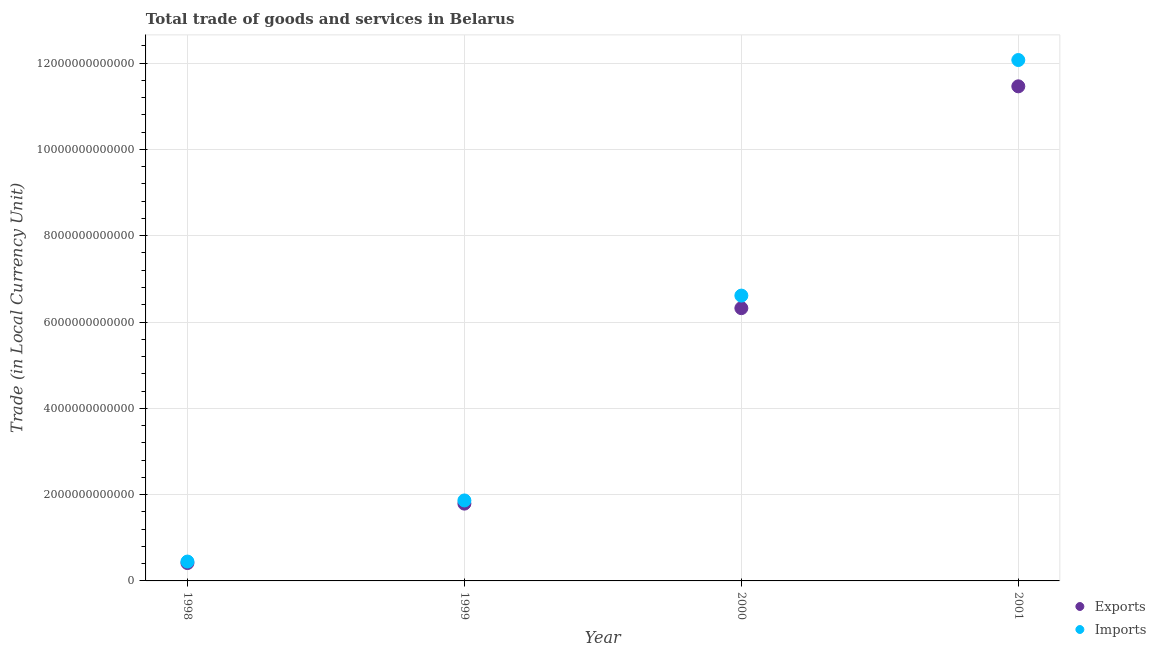What is the export of goods and services in 1998?
Ensure brevity in your answer.  4.15e+11. Across all years, what is the maximum imports of goods and services?
Your answer should be compact. 1.21e+13. Across all years, what is the minimum export of goods and services?
Offer a terse response. 4.15e+11. In which year was the export of goods and services maximum?
Give a very brief answer. 2001. In which year was the imports of goods and services minimum?
Give a very brief answer. 1998. What is the total imports of goods and services in the graph?
Offer a very short reply. 2.10e+13. What is the difference between the imports of goods and services in 1998 and that in 2001?
Ensure brevity in your answer.  -1.16e+13. What is the difference between the export of goods and services in 1998 and the imports of goods and services in 2000?
Keep it short and to the point. -6.20e+12. What is the average imports of goods and services per year?
Offer a very short reply. 5.25e+12. In the year 1998, what is the difference between the export of goods and services and imports of goods and services?
Your answer should be compact. -3.41e+1. What is the ratio of the imports of goods and services in 1998 to that in 1999?
Your answer should be compact. 0.24. What is the difference between the highest and the second highest export of goods and services?
Offer a very short reply. 5.14e+12. What is the difference between the highest and the lowest imports of goods and services?
Your answer should be very brief. 1.16e+13. In how many years, is the export of goods and services greater than the average export of goods and services taken over all years?
Your answer should be very brief. 2. Does the export of goods and services monotonically increase over the years?
Provide a succinct answer. Yes. Is the imports of goods and services strictly less than the export of goods and services over the years?
Make the answer very short. No. How many dotlines are there?
Your response must be concise. 2. What is the difference between two consecutive major ticks on the Y-axis?
Your answer should be very brief. 2.00e+12. Does the graph contain any zero values?
Your answer should be very brief. No. How many legend labels are there?
Provide a short and direct response. 2. What is the title of the graph?
Your answer should be very brief. Total trade of goods and services in Belarus. Does "GDP per capita" appear as one of the legend labels in the graph?
Your answer should be very brief. No. What is the label or title of the X-axis?
Your response must be concise. Year. What is the label or title of the Y-axis?
Ensure brevity in your answer.  Trade (in Local Currency Unit). What is the Trade (in Local Currency Unit) in Exports in 1998?
Keep it short and to the point. 4.15e+11. What is the Trade (in Local Currency Unit) of Imports in 1998?
Your answer should be compact. 4.49e+11. What is the Trade (in Local Currency Unit) in Exports in 1999?
Keep it short and to the point. 1.79e+12. What is the Trade (in Local Currency Unit) in Imports in 1999?
Keep it short and to the point. 1.87e+12. What is the Trade (in Local Currency Unit) in Exports in 2000?
Your answer should be compact. 6.32e+12. What is the Trade (in Local Currency Unit) in Imports in 2000?
Ensure brevity in your answer.  6.61e+12. What is the Trade (in Local Currency Unit) of Exports in 2001?
Offer a very short reply. 1.15e+13. What is the Trade (in Local Currency Unit) in Imports in 2001?
Provide a succinct answer. 1.21e+13. Across all years, what is the maximum Trade (in Local Currency Unit) of Exports?
Keep it short and to the point. 1.15e+13. Across all years, what is the maximum Trade (in Local Currency Unit) of Imports?
Make the answer very short. 1.21e+13. Across all years, what is the minimum Trade (in Local Currency Unit) of Exports?
Your answer should be very brief. 4.15e+11. Across all years, what is the minimum Trade (in Local Currency Unit) of Imports?
Your answer should be compact. 4.49e+11. What is the total Trade (in Local Currency Unit) of Exports in the graph?
Provide a short and direct response. 2.00e+13. What is the total Trade (in Local Currency Unit) of Imports in the graph?
Make the answer very short. 2.10e+13. What is the difference between the Trade (in Local Currency Unit) of Exports in 1998 and that in 1999?
Your response must be concise. -1.38e+12. What is the difference between the Trade (in Local Currency Unit) in Imports in 1998 and that in 1999?
Your answer should be very brief. -1.42e+12. What is the difference between the Trade (in Local Currency Unit) of Exports in 1998 and that in 2000?
Offer a very short reply. -5.91e+12. What is the difference between the Trade (in Local Currency Unit) in Imports in 1998 and that in 2000?
Make the answer very short. -6.16e+12. What is the difference between the Trade (in Local Currency Unit) in Exports in 1998 and that in 2001?
Provide a short and direct response. -1.10e+13. What is the difference between the Trade (in Local Currency Unit) in Imports in 1998 and that in 2001?
Your answer should be very brief. -1.16e+13. What is the difference between the Trade (in Local Currency Unit) in Exports in 1999 and that in 2000?
Your response must be concise. -4.53e+12. What is the difference between the Trade (in Local Currency Unit) of Imports in 1999 and that in 2000?
Offer a terse response. -4.75e+12. What is the difference between the Trade (in Local Currency Unit) in Exports in 1999 and that in 2001?
Offer a very short reply. -9.67e+12. What is the difference between the Trade (in Local Currency Unit) of Imports in 1999 and that in 2001?
Your response must be concise. -1.02e+13. What is the difference between the Trade (in Local Currency Unit) of Exports in 2000 and that in 2001?
Provide a succinct answer. -5.14e+12. What is the difference between the Trade (in Local Currency Unit) of Imports in 2000 and that in 2001?
Ensure brevity in your answer.  -5.46e+12. What is the difference between the Trade (in Local Currency Unit) in Exports in 1998 and the Trade (in Local Currency Unit) in Imports in 1999?
Offer a very short reply. -1.45e+12. What is the difference between the Trade (in Local Currency Unit) in Exports in 1998 and the Trade (in Local Currency Unit) in Imports in 2000?
Keep it short and to the point. -6.20e+12. What is the difference between the Trade (in Local Currency Unit) of Exports in 1998 and the Trade (in Local Currency Unit) of Imports in 2001?
Offer a terse response. -1.17e+13. What is the difference between the Trade (in Local Currency Unit) of Exports in 1999 and the Trade (in Local Currency Unit) of Imports in 2000?
Offer a terse response. -4.82e+12. What is the difference between the Trade (in Local Currency Unit) of Exports in 1999 and the Trade (in Local Currency Unit) of Imports in 2001?
Your answer should be compact. -1.03e+13. What is the difference between the Trade (in Local Currency Unit) in Exports in 2000 and the Trade (in Local Currency Unit) in Imports in 2001?
Ensure brevity in your answer.  -5.75e+12. What is the average Trade (in Local Currency Unit) of Exports per year?
Provide a short and direct response. 5.00e+12. What is the average Trade (in Local Currency Unit) of Imports per year?
Offer a terse response. 5.25e+12. In the year 1998, what is the difference between the Trade (in Local Currency Unit) of Exports and Trade (in Local Currency Unit) of Imports?
Ensure brevity in your answer.  -3.41e+1. In the year 1999, what is the difference between the Trade (in Local Currency Unit) in Exports and Trade (in Local Currency Unit) in Imports?
Your response must be concise. -7.35e+1. In the year 2000, what is the difference between the Trade (in Local Currency Unit) in Exports and Trade (in Local Currency Unit) in Imports?
Provide a short and direct response. -2.91e+11. In the year 2001, what is the difference between the Trade (in Local Currency Unit) in Exports and Trade (in Local Currency Unit) in Imports?
Offer a terse response. -6.10e+11. What is the ratio of the Trade (in Local Currency Unit) of Exports in 1998 to that in 1999?
Provide a succinct answer. 0.23. What is the ratio of the Trade (in Local Currency Unit) in Imports in 1998 to that in 1999?
Offer a terse response. 0.24. What is the ratio of the Trade (in Local Currency Unit) of Exports in 1998 to that in 2000?
Provide a short and direct response. 0.07. What is the ratio of the Trade (in Local Currency Unit) of Imports in 1998 to that in 2000?
Provide a short and direct response. 0.07. What is the ratio of the Trade (in Local Currency Unit) of Exports in 1998 to that in 2001?
Give a very brief answer. 0.04. What is the ratio of the Trade (in Local Currency Unit) in Imports in 1998 to that in 2001?
Your answer should be compact. 0.04. What is the ratio of the Trade (in Local Currency Unit) in Exports in 1999 to that in 2000?
Your response must be concise. 0.28. What is the ratio of the Trade (in Local Currency Unit) of Imports in 1999 to that in 2000?
Ensure brevity in your answer.  0.28. What is the ratio of the Trade (in Local Currency Unit) in Exports in 1999 to that in 2001?
Keep it short and to the point. 0.16. What is the ratio of the Trade (in Local Currency Unit) in Imports in 1999 to that in 2001?
Ensure brevity in your answer.  0.15. What is the ratio of the Trade (in Local Currency Unit) of Exports in 2000 to that in 2001?
Your answer should be compact. 0.55. What is the ratio of the Trade (in Local Currency Unit) of Imports in 2000 to that in 2001?
Give a very brief answer. 0.55. What is the difference between the highest and the second highest Trade (in Local Currency Unit) in Exports?
Your response must be concise. 5.14e+12. What is the difference between the highest and the second highest Trade (in Local Currency Unit) of Imports?
Make the answer very short. 5.46e+12. What is the difference between the highest and the lowest Trade (in Local Currency Unit) of Exports?
Offer a terse response. 1.10e+13. What is the difference between the highest and the lowest Trade (in Local Currency Unit) of Imports?
Your answer should be compact. 1.16e+13. 